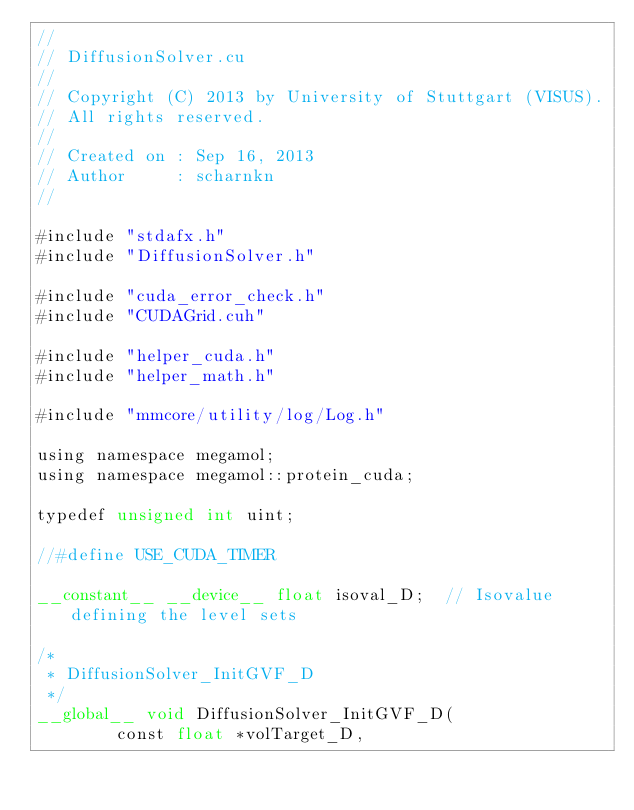Convert code to text. <code><loc_0><loc_0><loc_500><loc_500><_Cuda_>//
// DiffusionSolver.cu
//
// Copyright (C) 2013 by University of Stuttgart (VISUS).
// All rights reserved.
//
// Created on : Sep 16, 2013
// Author     : scharnkn
//

#include "stdafx.h"
#include "DiffusionSolver.h"

#include "cuda_error_check.h"
#include "CUDAGrid.cuh"

#include "helper_cuda.h"
#include "helper_math.h"

#include "mmcore/utility/log/Log.h"

using namespace megamol;
using namespace megamol::protein_cuda;

typedef unsigned int uint;

//#define USE_CUDA_TIMER

__constant__ __device__ float isoval_D;  // Isovalue defining the level sets

/*
 * DiffusionSolver_InitGVF_D
 */
__global__ void DiffusionSolver_InitGVF_D(
        const float *volTarget_D,</code> 